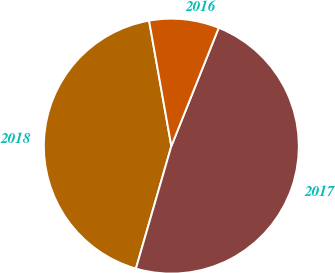Convert chart. <chart><loc_0><loc_0><loc_500><loc_500><pie_chart><fcel>2018<fcel>2017<fcel>2016<nl><fcel>42.72%<fcel>48.42%<fcel>8.86%<nl></chart> 